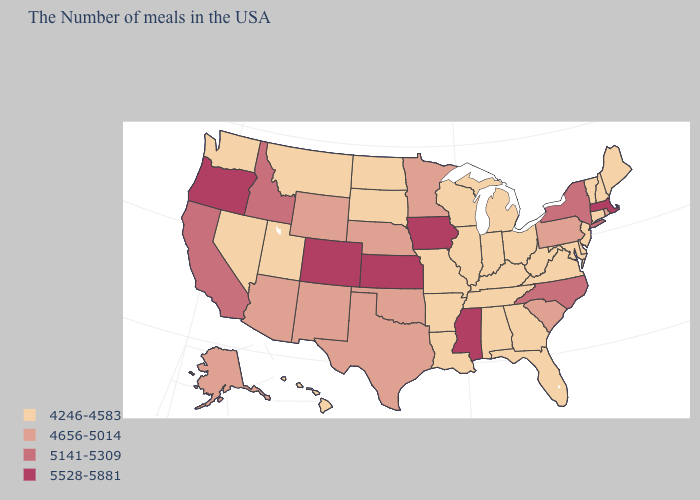How many symbols are there in the legend?
Give a very brief answer. 4. Does the map have missing data?
Quick response, please. No. Among the states that border West Virginia , which have the lowest value?
Short answer required. Maryland, Virginia, Ohio, Kentucky. Name the states that have a value in the range 4246-4583?
Be succinct. Maine, New Hampshire, Vermont, Connecticut, New Jersey, Delaware, Maryland, Virginia, West Virginia, Ohio, Florida, Georgia, Michigan, Kentucky, Indiana, Alabama, Tennessee, Wisconsin, Illinois, Louisiana, Missouri, Arkansas, South Dakota, North Dakota, Utah, Montana, Nevada, Washington, Hawaii. What is the value of Texas?
Answer briefly. 4656-5014. Does the first symbol in the legend represent the smallest category?
Give a very brief answer. Yes. Which states have the lowest value in the Northeast?
Keep it brief. Maine, New Hampshire, Vermont, Connecticut, New Jersey. Name the states that have a value in the range 5528-5881?
Give a very brief answer. Massachusetts, Mississippi, Iowa, Kansas, Colorado, Oregon. Name the states that have a value in the range 5141-5309?
Be succinct. New York, North Carolina, Idaho, California. Among the states that border Minnesota , does South Dakota have the lowest value?
Keep it brief. Yes. Which states hav the highest value in the Northeast?
Keep it brief. Massachusetts. Name the states that have a value in the range 5141-5309?
Answer briefly. New York, North Carolina, Idaho, California. Does Indiana have the highest value in the USA?
Give a very brief answer. No. Name the states that have a value in the range 5528-5881?
Short answer required. Massachusetts, Mississippi, Iowa, Kansas, Colorado, Oregon. Name the states that have a value in the range 4246-4583?
Concise answer only. Maine, New Hampshire, Vermont, Connecticut, New Jersey, Delaware, Maryland, Virginia, West Virginia, Ohio, Florida, Georgia, Michigan, Kentucky, Indiana, Alabama, Tennessee, Wisconsin, Illinois, Louisiana, Missouri, Arkansas, South Dakota, North Dakota, Utah, Montana, Nevada, Washington, Hawaii. 